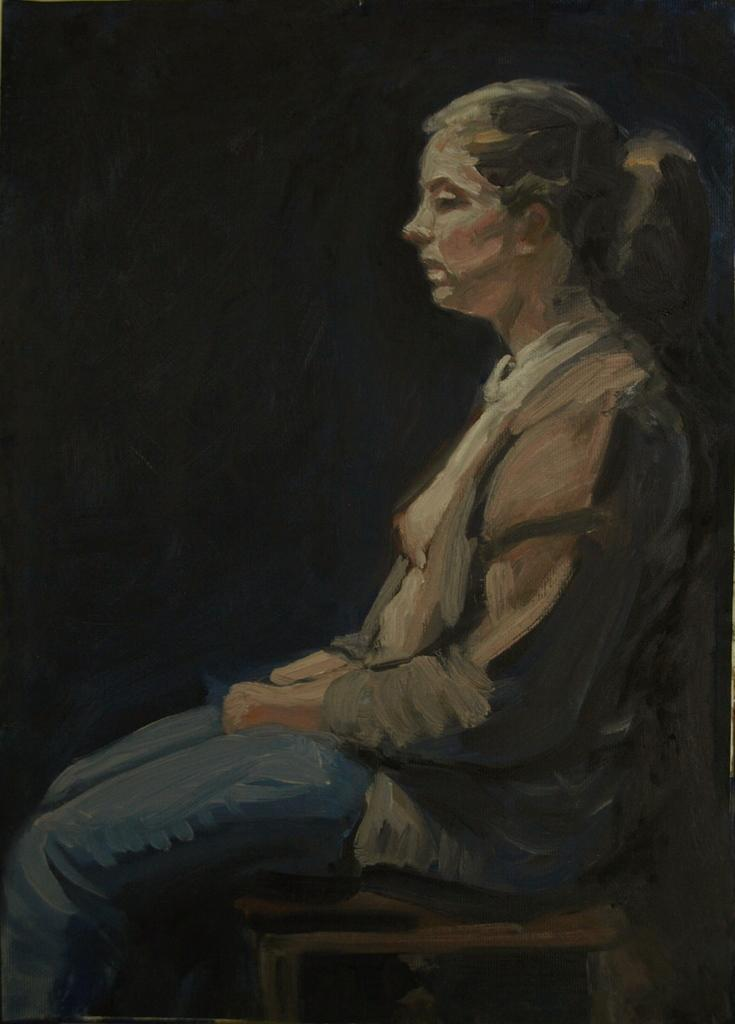What is depicted in the image? There is a painting of a woman in the image. Can you describe the background of the painting? The background of the painting is black. What type of knowledge can be gained from the boat in the image? There is no boat present in the image, so no knowledge can be gained from it. 